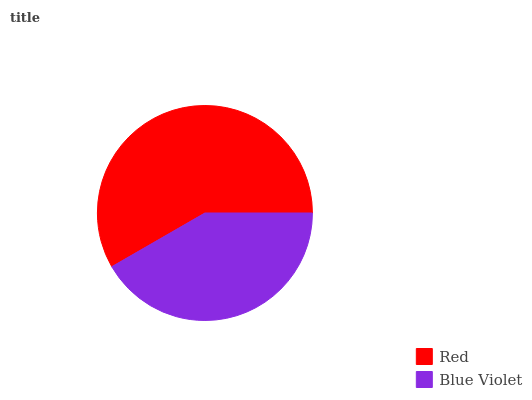Is Blue Violet the minimum?
Answer yes or no. Yes. Is Red the maximum?
Answer yes or no. Yes. Is Blue Violet the maximum?
Answer yes or no. No. Is Red greater than Blue Violet?
Answer yes or no. Yes. Is Blue Violet less than Red?
Answer yes or no. Yes. Is Blue Violet greater than Red?
Answer yes or no. No. Is Red less than Blue Violet?
Answer yes or no. No. Is Red the high median?
Answer yes or no. Yes. Is Blue Violet the low median?
Answer yes or no. Yes. Is Blue Violet the high median?
Answer yes or no. No. Is Red the low median?
Answer yes or no. No. 